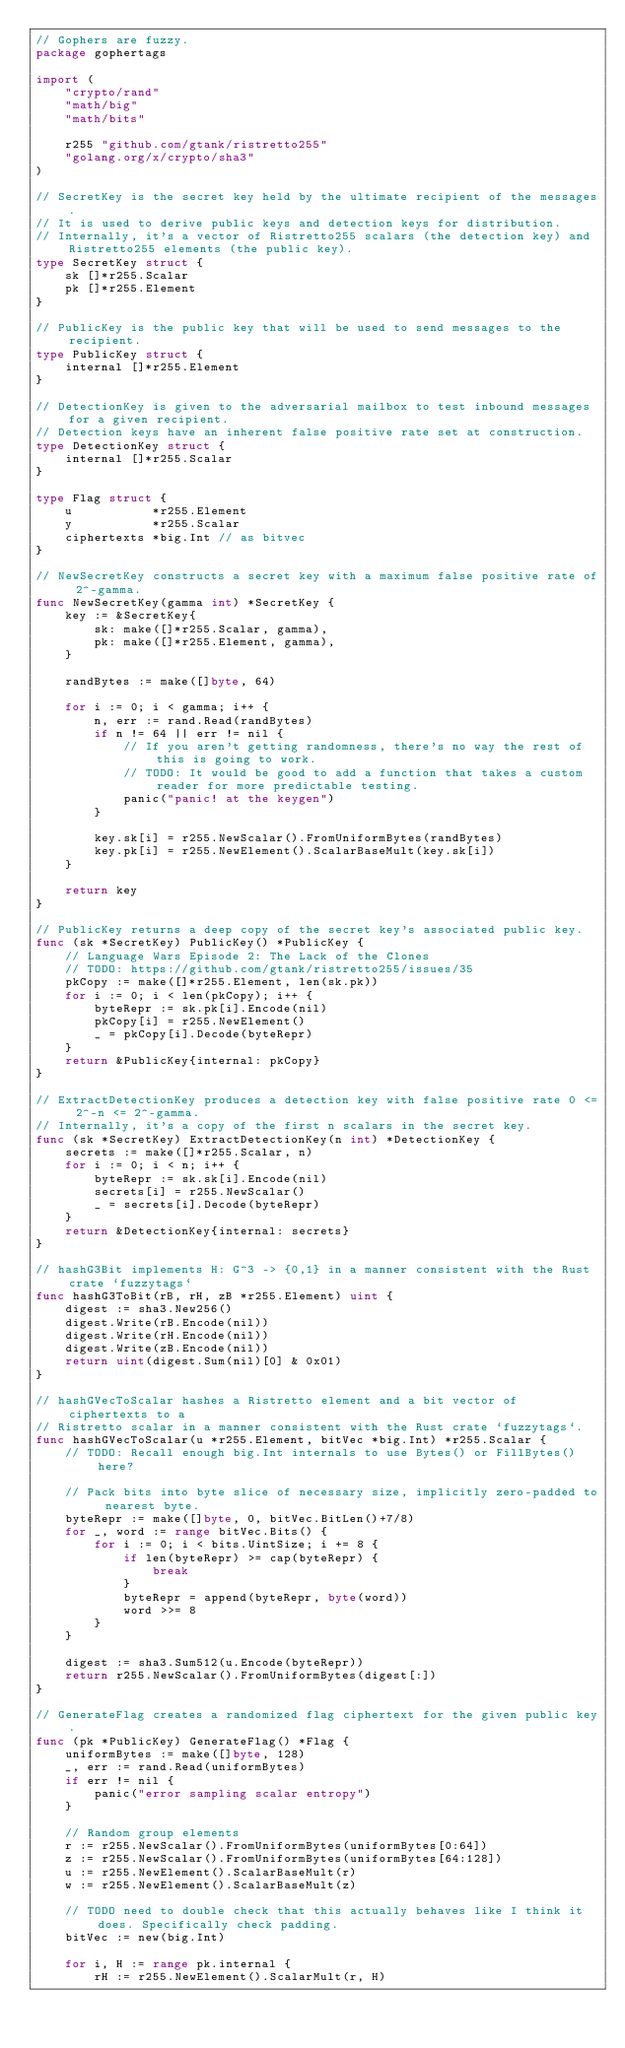<code> <loc_0><loc_0><loc_500><loc_500><_Go_>// Gophers are fuzzy.
package gophertags

import (
	"crypto/rand"
	"math/big"
	"math/bits"

	r255 "github.com/gtank/ristretto255"
	"golang.org/x/crypto/sha3"
)

// SecretKey is the secret key held by the ultimate recipient of the messages.
// It is used to derive public keys and detection keys for distribution.
// Internally, it's a vector of Ristretto255 scalars (the detection key) and Ristretto255 elements (the public key).
type SecretKey struct {
	sk []*r255.Scalar
	pk []*r255.Element
}

// PublicKey is the public key that will be used to send messages to the recipient.
type PublicKey struct {
	internal []*r255.Element
}

// DetectionKey is given to the adversarial mailbox to test inbound messages for a given recipient.
// Detection keys have an inherent false positive rate set at construction.
type DetectionKey struct {
	internal []*r255.Scalar
}

type Flag struct {
	u           *r255.Element
	y           *r255.Scalar
	ciphertexts *big.Int // as bitvec
}

// NewSecretKey constructs a secret key with a maximum false positive rate of 2^-gamma.
func NewSecretKey(gamma int) *SecretKey {
	key := &SecretKey{
		sk: make([]*r255.Scalar, gamma),
		pk: make([]*r255.Element, gamma),
	}

	randBytes := make([]byte, 64)

	for i := 0; i < gamma; i++ {
		n, err := rand.Read(randBytes)
		if n != 64 || err != nil {
			// If you aren't getting randomness, there's no way the rest of this is going to work.
			// TODO: It would be good to add a function that takes a custom reader for more predictable testing.
			panic("panic! at the keygen")
		}

		key.sk[i] = r255.NewScalar().FromUniformBytes(randBytes)
		key.pk[i] = r255.NewElement().ScalarBaseMult(key.sk[i])
	}

	return key
}

// PublicKey returns a deep copy of the secret key's associated public key.
func (sk *SecretKey) PublicKey() *PublicKey {
	// Language Wars Episode 2: The Lack of the Clones
	// TODO: https://github.com/gtank/ristretto255/issues/35
	pkCopy := make([]*r255.Element, len(sk.pk))
	for i := 0; i < len(pkCopy); i++ {
		byteRepr := sk.pk[i].Encode(nil)
		pkCopy[i] = r255.NewElement()
		_ = pkCopy[i].Decode(byteRepr)
	}
	return &PublicKey{internal: pkCopy}
}

// ExtractDetectionKey produces a detection key with false positive rate 0 <= 2^-n <= 2^-gamma.
// Internally, it's a copy of the first n scalars in the secret key.
func (sk *SecretKey) ExtractDetectionKey(n int) *DetectionKey {
	secrets := make([]*r255.Scalar, n)
	for i := 0; i < n; i++ {
		byteRepr := sk.sk[i].Encode(nil)
		secrets[i] = r255.NewScalar()
		_ = secrets[i].Decode(byteRepr)
	}
	return &DetectionKey{internal: secrets}
}

// hashG3Bit implements H: G^3 -> {0,1} in a manner consistent with the Rust crate `fuzzytags`
func hashG3ToBit(rB, rH, zB *r255.Element) uint {
	digest := sha3.New256()
	digest.Write(rB.Encode(nil))
	digest.Write(rH.Encode(nil))
	digest.Write(zB.Encode(nil))
	return uint(digest.Sum(nil)[0] & 0x01)
}

// hashGVecToScalar hashes a Ristretto element and a bit vector of ciphertexts to a
// Ristretto scalar in a manner consistent with the Rust crate `fuzzytags`.
func hashGVecToScalar(u *r255.Element, bitVec *big.Int) *r255.Scalar {
	// TODO: Recall enough big.Int internals to use Bytes() or FillBytes() here?

	// Pack bits into byte slice of necessary size, implicitly zero-padded to nearest byte.
	byteRepr := make([]byte, 0, bitVec.BitLen()+7/8)
	for _, word := range bitVec.Bits() {
		for i := 0; i < bits.UintSize; i += 8 {
			if len(byteRepr) >= cap(byteRepr) {
				break
			}
			byteRepr = append(byteRepr, byte(word))
			word >>= 8
		}
	}

	digest := sha3.Sum512(u.Encode(byteRepr))
	return r255.NewScalar().FromUniformBytes(digest[:])
}

// GenerateFlag creates a randomized flag ciphertext for the given public key.
func (pk *PublicKey) GenerateFlag() *Flag {
	uniformBytes := make([]byte, 128)
	_, err := rand.Read(uniformBytes)
	if err != nil {
		panic("error sampling scalar entropy")
	}

	// Random group elements
	r := r255.NewScalar().FromUniformBytes(uniformBytes[0:64])
	z := r255.NewScalar().FromUniformBytes(uniformBytes[64:128])
	u := r255.NewElement().ScalarBaseMult(r)
	w := r255.NewElement().ScalarBaseMult(z)

	// TODO need to double check that this actually behaves like I think it does. Specifically check padding.
	bitVec := new(big.Int)

	for i, H := range pk.internal {
		rH := r255.NewElement().ScalarMult(r, H)</code> 